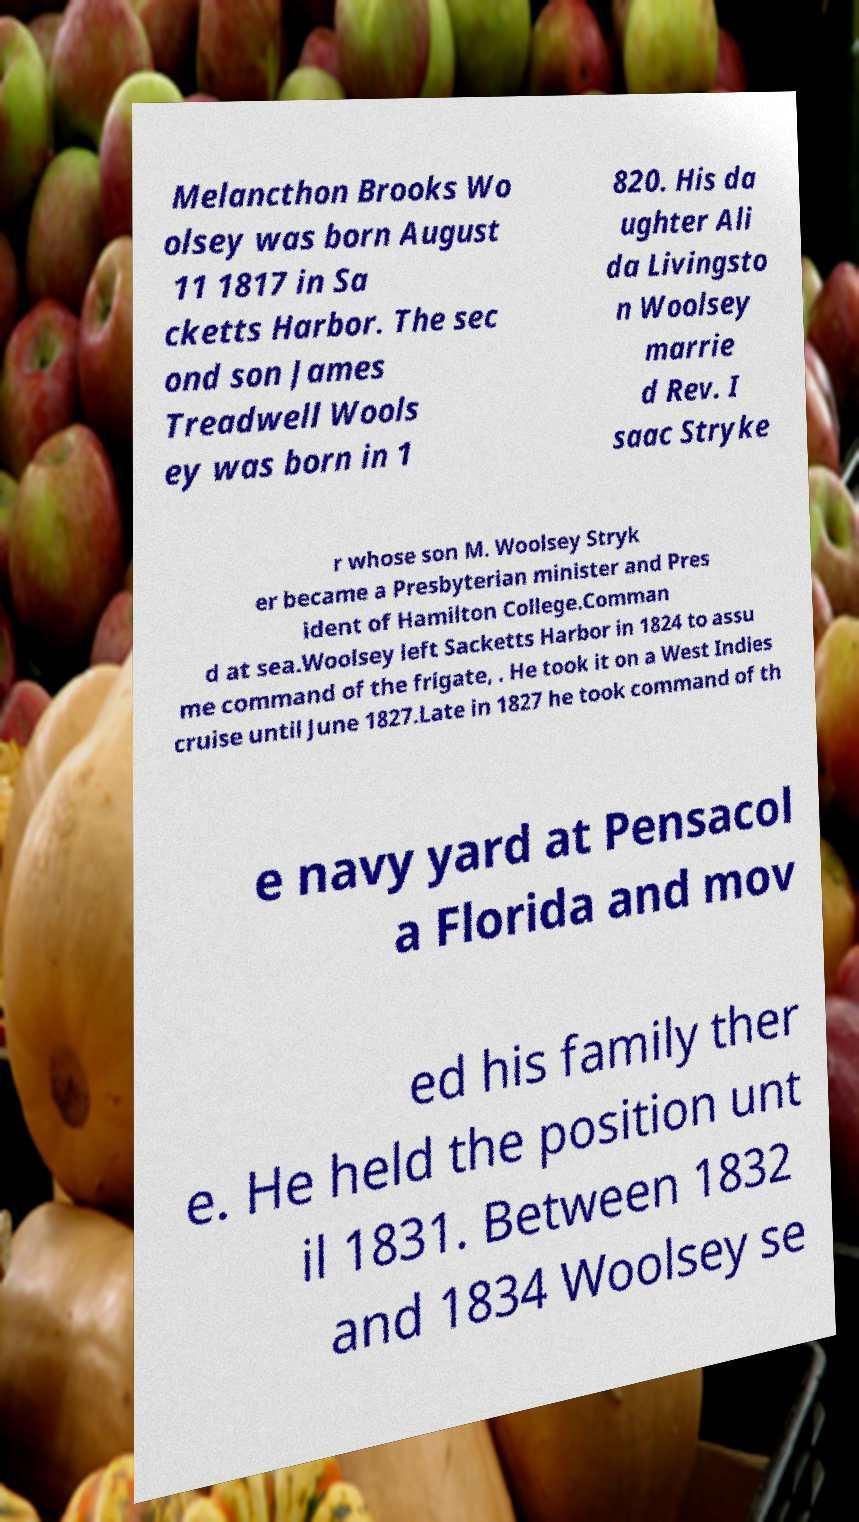Could you extract and type out the text from this image? Melancthon Brooks Wo olsey was born August 11 1817 in Sa cketts Harbor. The sec ond son James Treadwell Wools ey was born in 1 820. His da ughter Ali da Livingsto n Woolsey marrie d Rev. I saac Stryke r whose son M. Woolsey Stryk er became a Presbyterian minister and Pres ident of Hamilton College.Comman d at sea.Woolsey left Sacketts Harbor in 1824 to assu me command of the frigate, . He took it on a West Indies cruise until June 1827.Late in 1827 he took command of th e navy yard at Pensacol a Florida and mov ed his family ther e. He held the position unt il 1831. Between 1832 and 1834 Woolsey se 